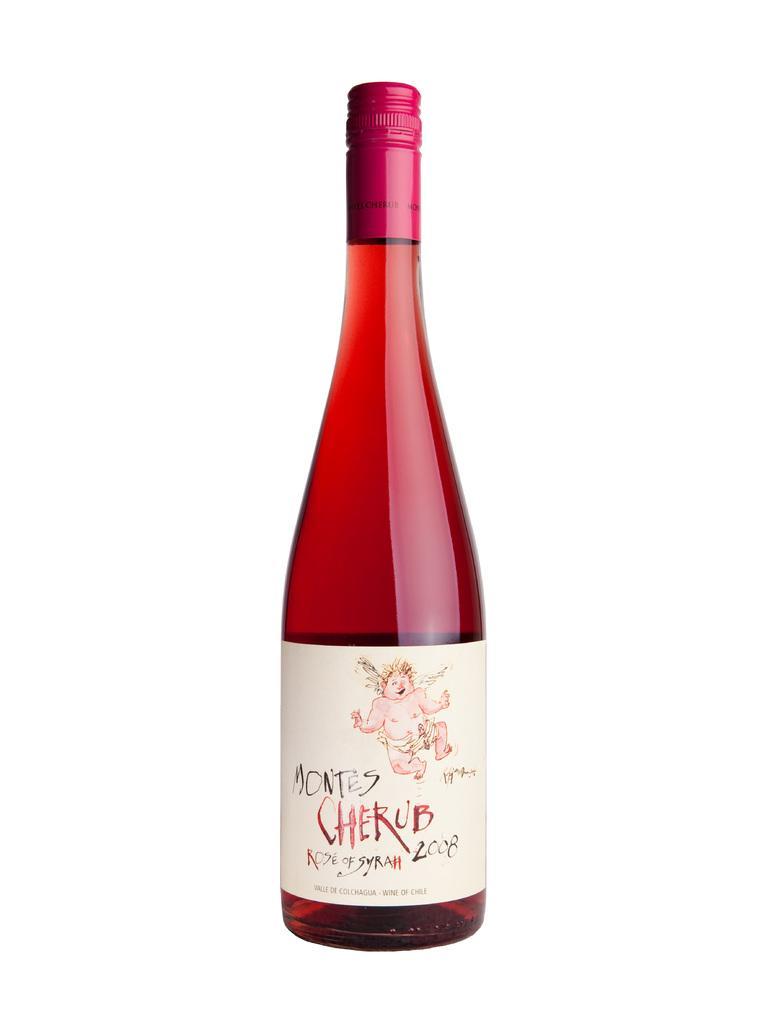Describe this image in one or two sentences. In this picture there is a glass bottle containing a drink, which is sealed and the background is white in color. 